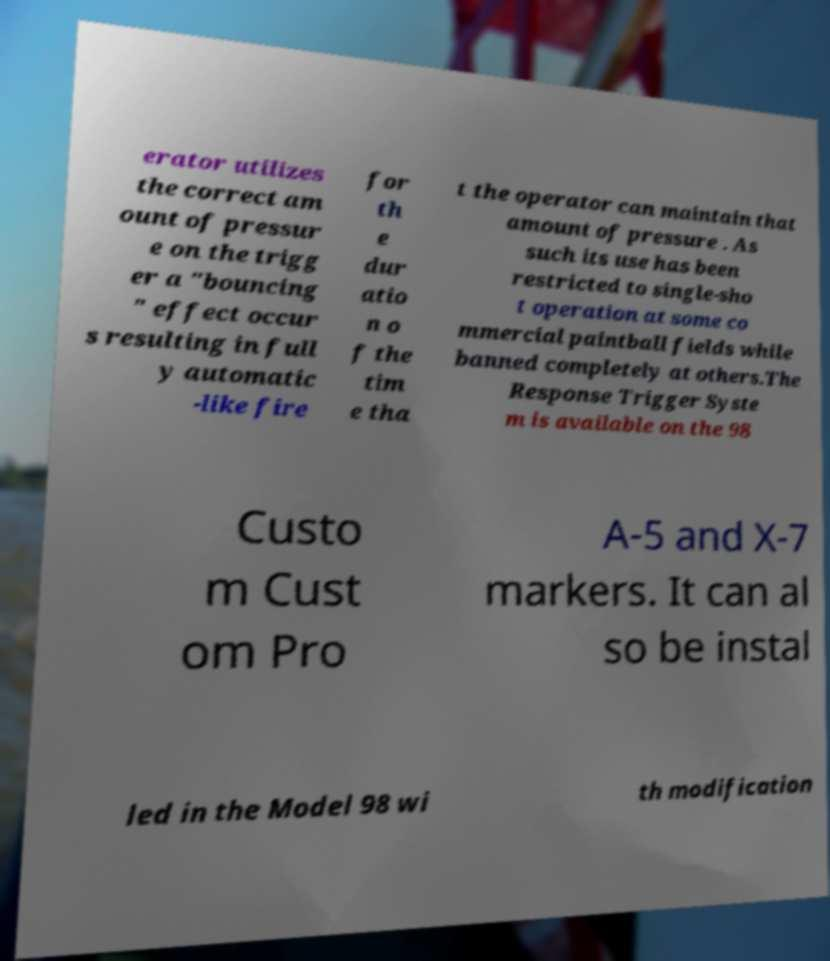Please read and relay the text visible in this image. What does it say? erator utilizes the correct am ount of pressur e on the trigg er a "bouncing " effect occur s resulting in full y automatic -like fire for th e dur atio n o f the tim e tha t the operator can maintain that amount of pressure . As such its use has been restricted to single-sho t operation at some co mmercial paintball fields while banned completely at others.The Response Trigger Syste m is available on the 98 Custo m Cust om Pro A-5 and X-7 markers. It can al so be instal led in the Model 98 wi th modification 